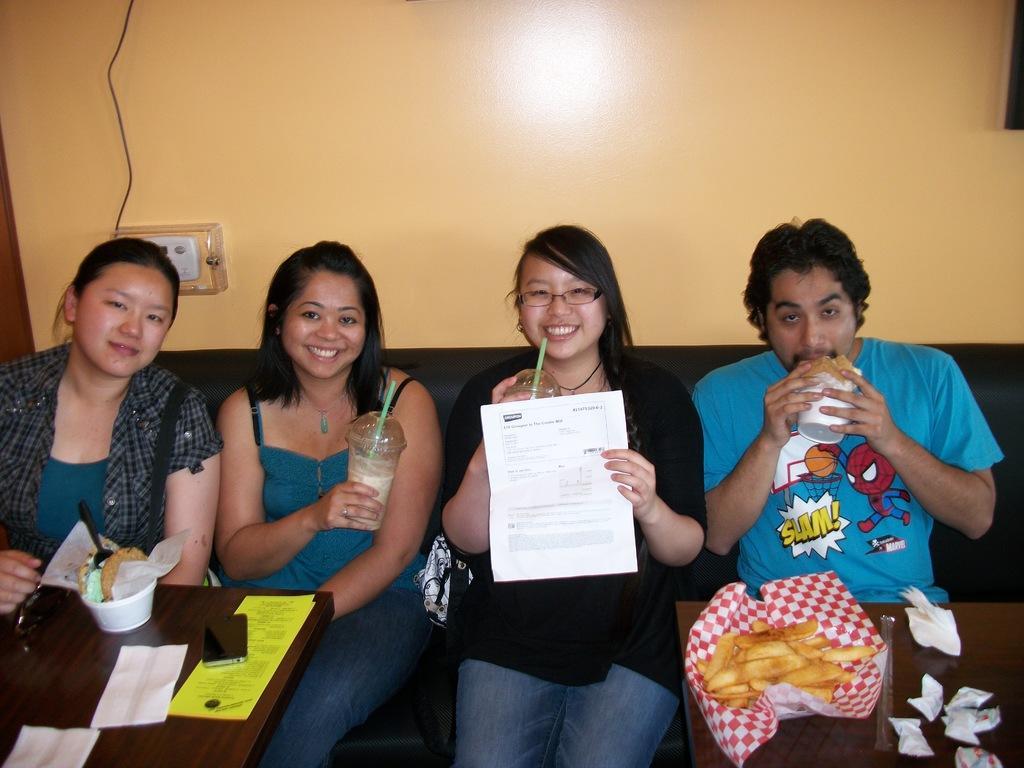Can you describe this image briefly? In this picture there are people sitting on sofa, among them there is a man holding food and there are women smiling. We can see cover, papers, food, mobile and cup on tables. In the background of the image we can see switch board and cable on the wall. 